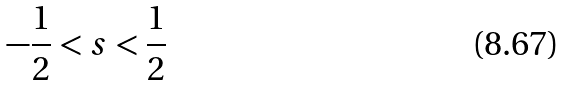Convert formula to latex. <formula><loc_0><loc_0><loc_500><loc_500>- \frac { 1 } { 2 } < s < \frac { 1 } { 2 }</formula> 